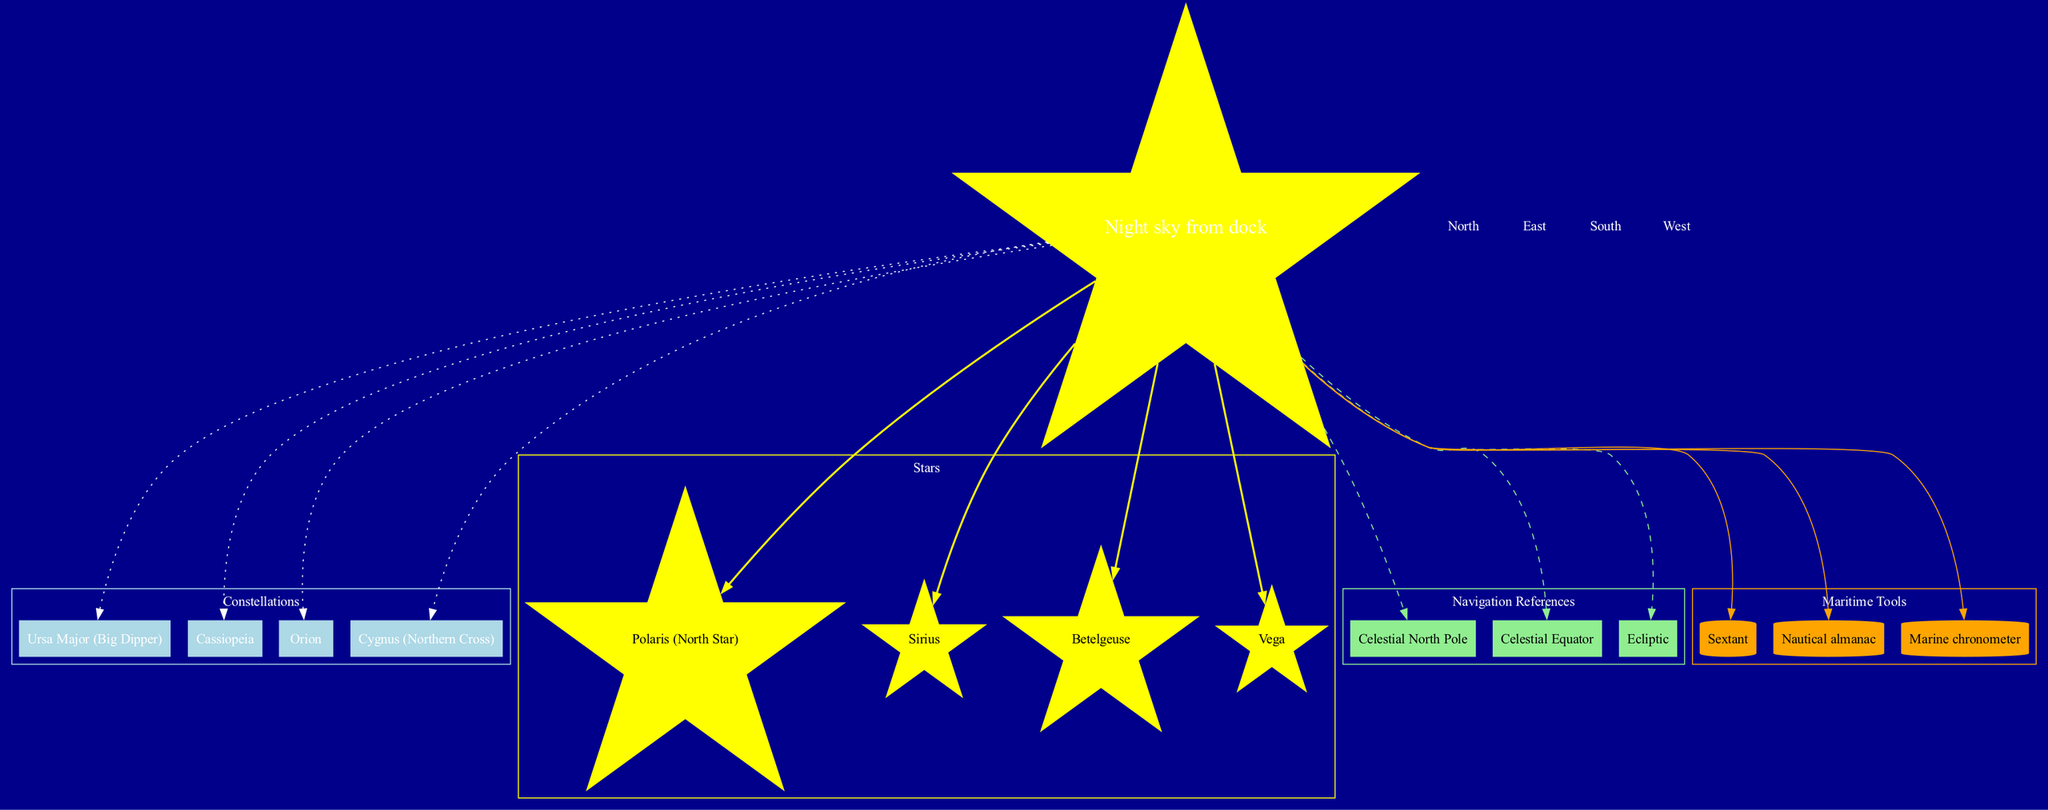What are the constellations listed in the diagram? The diagram displays four constellations: Ursa Major (Big Dipper), Cassiopeia, Orion, and Cygnus (Northern Cross).
Answer: Ursa Major (Big Dipper), Cassiopeia, Orion, Cygnus (Northern Cross) How many stars are shown in the diagram? There are four stars depicted in the diagram: Polaris (North Star), Sirius, Betelgeuse, and Vega.
Answer: 4 What shape represents the North Star? The North Star, Polaris, is represented in the diagram by a star shape.
Answer: Star Which navigation reference is depicted as a box shape? The navigation references are shown as boxes, with the Celestial North Pole, Celestial Equator, and Ecliptic being included in that category.
Answer: Box What tool is cited as a cylinder in the diagram? The maritime tool represented as a cylinder is the Nautical Almanac, which is included among other maritime tools like the Sextant and Marine Chronometer.
Answer: Nautical almanac How many directions are specified in the diagram? The diagram specifies four key directions: North, East, South, and West.
Answer: 4 Which constellation is located in the direction of the North? The diagram does not specifically point to a constellation but indicates that Ursa Major (Big Dipper) is often used for navigation to locate the North Star, which is towards the North.
Answer: Ursa Major (Big Dipper) What is the color of the boxes representing navigation references? The boxes representing navigation references are colored light green in the diagram.
Answer: Light green Which star is associated with the color yellow in the diagram? All stars in the diagram, including Polaris, Sirius, Betelgeuse, and Vega, are represented using a yellow color.
Answer: Yellow 